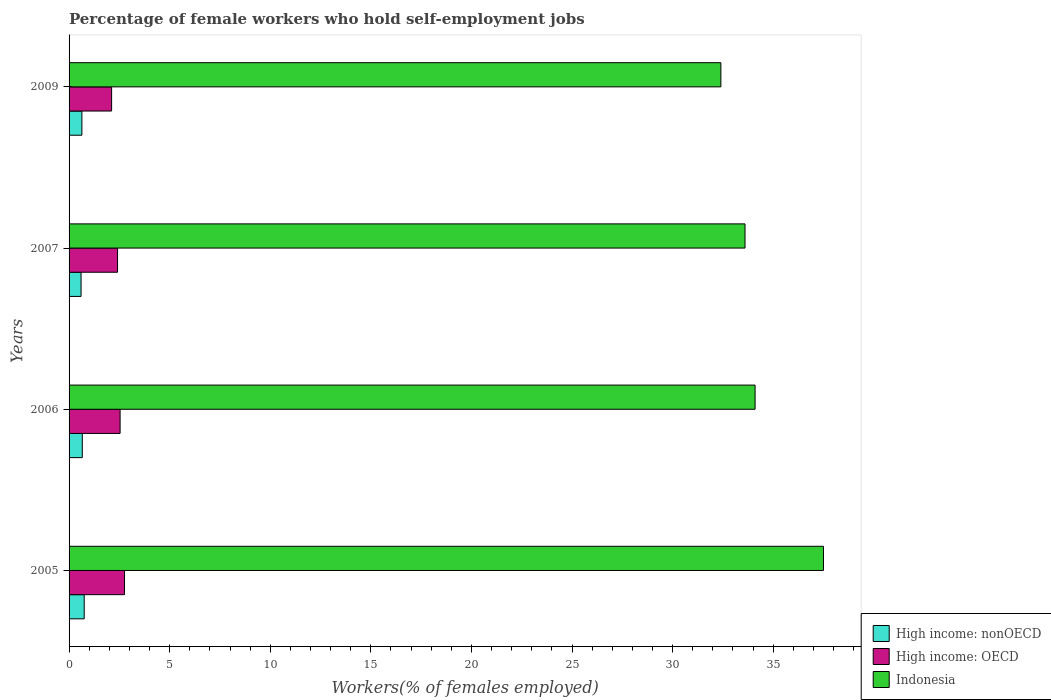What is the percentage of self-employed female workers in Indonesia in 2005?
Offer a very short reply. 37.5. Across all years, what is the maximum percentage of self-employed female workers in Indonesia?
Your answer should be compact. 37.5. Across all years, what is the minimum percentage of self-employed female workers in Indonesia?
Offer a very short reply. 32.4. In which year was the percentage of self-employed female workers in High income: nonOECD maximum?
Make the answer very short. 2005. What is the total percentage of self-employed female workers in High income: OECD in the graph?
Provide a short and direct response. 9.82. What is the difference between the percentage of self-employed female workers in High income: nonOECD in 2006 and that in 2007?
Provide a succinct answer. 0.06. What is the difference between the percentage of self-employed female workers in High income: nonOECD in 2005 and the percentage of self-employed female workers in Indonesia in 2009?
Your answer should be compact. -31.65. What is the average percentage of self-employed female workers in High income: nonOECD per year?
Provide a succinct answer. 0.66. In the year 2006, what is the difference between the percentage of self-employed female workers in High income: nonOECD and percentage of self-employed female workers in High income: OECD?
Provide a succinct answer. -1.88. In how many years, is the percentage of self-employed female workers in High income: OECD greater than 3 %?
Make the answer very short. 0. What is the ratio of the percentage of self-employed female workers in High income: nonOECD in 2006 to that in 2009?
Your response must be concise. 1.03. Is the difference between the percentage of self-employed female workers in High income: nonOECD in 2005 and 2007 greater than the difference between the percentage of self-employed female workers in High income: OECD in 2005 and 2007?
Offer a very short reply. No. What is the difference between the highest and the second highest percentage of self-employed female workers in Indonesia?
Your answer should be compact. 3.4. What is the difference between the highest and the lowest percentage of self-employed female workers in Indonesia?
Provide a succinct answer. 5.1. In how many years, is the percentage of self-employed female workers in High income: OECD greater than the average percentage of self-employed female workers in High income: OECD taken over all years?
Your response must be concise. 2. What does the 3rd bar from the top in 2005 represents?
Offer a very short reply. High income: nonOECD. Is it the case that in every year, the sum of the percentage of self-employed female workers in High income: OECD and percentage of self-employed female workers in Indonesia is greater than the percentage of self-employed female workers in High income: nonOECD?
Give a very brief answer. Yes. How many bars are there?
Offer a terse response. 12. Are all the bars in the graph horizontal?
Make the answer very short. Yes. How many years are there in the graph?
Provide a short and direct response. 4. Does the graph contain any zero values?
Keep it short and to the point. No. Does the graph contain grids?
Give a very brief answer. No. Where does the legend appear in the graph?
Make the answer very short. Bottom right. How many legend labels are there?
Keep it short and to the point. 3. What is the title of the graph?
Make the answer very short. Percentage of female workers who hold self-employment jobs. What is the label or title of the X-axis?
Your answer should be very brief. Workers(% of females employed). What is the label or title of the Y-axis?
Your answer should be very brief. Years. What is the Workers(% of females employed) in High income: nonOECD in 2005?
Provide a short and direct response. 0.75. What is the Workers(% of females employed) in High income: OECD in 2005?
Make the answer very short. 2.76. What is the Workers(% of females employed) in Indonesia in 2005?
Keep it short and to the point. 37.5. What is the Workers(% of females employed) of High income: nonOECD in 2006?
Give a very brief answer. 0.66. What is the Workers(% of females employed) of High income: OECD in 2006?
Your response must be concise. 2.54. What is the Workers(% of females employed) of Indonesia in 2006?
Provide a short and direct response. 34.1. What is the Workers(% of females employed) in High income: nonOECD in 2007?
Your answer should be compact. 0.6. What is the Workers(% of females employed) of High income: OECD in 2007?
Give a very brief answer. 2.41. What is the Workers(% of females employed) of Indonesia in 2007?
Your response must be concise. 33.6. What is the Workers(% of females employed) of High income: nonOECD in 2009?
Provide a short and direct response. 0.64. What is the Workers(% of females employed) of High income: OECD in 2009?
Your answer should be very brief. 2.11. What is the Workers(% of females employed) of Indonesia in 2009?
Provide a short and direct response. 32.4. Across all years, what is the maximum Workers(% of females employed) in High income: nonOECD?
Make the answer very short. 0.75. Across all years, what is the maximum Workers(% of females employed) in High income: OECD?
Your answer should be very brief. 2.76. Across all years, what is the maximum Workers(% of females employed) in Indonesia?
Offer a terse response. 37.5. Across all years, what is the minimum Workers(% of females employed) in High income: nonOECD?
Provide a succinct answer. 0.6. Across all years, what is the minimum Workers(% of females employed) in High income: OECD?
Provide a short and direct response. 2.11. Across all years, what is the minimum Workers(% of females employed) of Indonesia?
Keep it short and to the point. 32.4. What is the total Workers(% of females employed) of High income: nonOECD in the graph?
Keep it short and to the point. 2.64. What is the total Workers(% of females employed) of High income: OECD in the graph?
Provide a succinct answer. 9.82. What is the total Workers(% of females employed) in Indonesia in the graph?
Your answer should be very brief. 137.6. What is the difference between the Workers(% of females employed) of High income: nonOECD in 2005 and that in 2006?
Ensure brevity in your answer.  0.1. What is the difference between the Workers(% of females employed) in High income: OECD in 2005 and that in 2006?
Provide a succinct answer. 0.22. What is the difference between the Workers(% of females employed) of Indonesia in 2005 and that in 2006?
Your response must be concise. 3.4. What is the difference between the Workers(% of females employed) in High income: nonOECD in 2005 and that in 2007?
Your answer should be compact. 0.16. What is the difference between the Workers(% of females employed) of High income: OECD in 2005 and that in 2007?
Your answer should be very brief. 0.35. What is the difference between the Workers(% of females employed) of Indonesia in 2005 and that in 2007?
Provide a short and direct response. 3.9. What is the difference between the Workers(% of females employed) in High income: nonOECD in 2005 and that in 2009?
Ensure brevity in your answer.  0.11. What is the difference between the Workers(% of females employed) in High income: OECD in 2005 and that in 2009?
Offer a terse response. 0.64. What is the difference between the Workers(% of females employed) in High income: nonOECD in 2006 and that in 2007?
Provide a short and direct response. 0.06. What is the difference between the Workers(% of females employed) of High income: OECD in 2006 and that in 2007?
Make the answer very short. 0.13. What is the difference between the Workers(% of females employed) of Indonesia in 2006 and that in 2007?
Make the answer very short. 0.5. What is the difference between the Workers(% of females employed) of High income: nonOECD in 2006 and that in 2009?
Offer a very short reply. 0.02. What is the difference between the Workers(% of females employed) of High income: OECD in 2006 and that in 2009?
Offer a terse response. 0.42. What is the difference between the Workers(% of females employed) of High income: nonOECD in 2007 and that in 2009?
Your answer should be very brief. -0.04. What is the difference between the Workers(% of females employed) in High income: OECD in 2007 and that in 2009?
Give a very brief answer. 0.3. What is the difference between the Workers(% of females employed) in Indonesia in 2007 and that in 2009?
Offer a very short reply. 1.2. What is the difference between the Workers(% of females employed) in High income: nonOECD in 2005 and the Workers(% of females employed) in High income: OECD in 2006?
Ensure brevity in your answer.  -1.78. What is the difference between the Workers(% of females employed) in High income: nonOECD in 2005 and the Workers(% of females employed) in Indonesia in 2006?
Ensure brevity in your answer.  -33.35. What is the difference between the Workers(% of females employed) of High income: OECD in 2005 and the Workers(% of females employed) of Indonesia in 2006?
Offer a terse response. -31.34. What is the difference between the Workers(% of females employed) of High income: nonOECD in 2005 and the Workers(% of females employed) of High income: OECD in 2007?
Offer a terse response. -1.66. What is the difference between the Workers(% of females employed) in High income: nonOECD in 2005 and the Workers(% of females employed) in Indonesia in 2007?
Offer a terse response. -32.85. What is the difference between the Workers(% of females employed) of High income: OECD in 2005 and the Workers(% of females employed) of Indonesia in 2007?
Your answer should be compact. -30.84. What is the difference between the Workers(% of females employed) of High income: nonOECD in 2005 and the Workers(% of females employed) of High income: OECD in 2009?
Offer a very short reply. -1.36. What is the difference between the Workers(% of females employed) in High income: nonOECD in 2005 and the Workers(% of females employed) in Indonesia in 2009?
Make the answer very short. -31.65. What is the difference between the Workers(% of females employed) in High income: OECD in 2005 and the Workers(% of females employed) in Indonesia in 2009?
Your response must be concise. -29.64. What is the difference between the Workers(% of females employed) in High income: nonOECD in 2006 and the Workers(% of females employed) in High income: OECD in 2007?
Your answer should be very brief. -1.75. What is the difference between the Workers(% of females employed) of High income: nonOECD in 2006 and the Workers(% of females employed) of Indonesia in 2007?
Your response must be concise. -32.94. What is the difference between the Workers(% of females employed) of High income: OECD in 2006 and the Workers(% of females employed) of Indonesia in 2007?
Your answer should be compact. -31.06. What is the difference between the Workers(% of females employed) in High income: nonOECD in 2006 and the Workers(% of females employed) in High income: OECD in 2009?
Make the answer very short. -1.46. What is the difference between the Workers(% of females employed) of High income: nonOECD in 2006 and the Workers(% of females employed) of Indonesia in 2009?
Make the answer very short. -31.74. What is the difference between the Workers(% of females employed) of High income: OECD in 2006 and the Workers(% of females employed) of Indonesia in 2009?
Offer a very short reply. -29.86. What is the difference between the Workers(% of females employed) of High income: nonOECD in 2007 and the Workers(% of females employed) of High income: OECD in 2009?
Make the answer very short. -1.52. What is the difference between the Workers(% of females employed) in High income: nonOECD in 2007 and the Workers(% of females employed) in Indonesia in 2009?
Give a very brief answer. -31.8. What is the difference between the Workers(% of females employed) in High income: OECD in 2007 and the Workers(% of females employed) in Indonesia in 2009?
Ensure brevity in your answer.  -29.99. What is the average Workers(% of females employed) in High income: nonOECD per year?
Keep it short and to the point. 0.66. What is the average Workers(% of females employed) in High income: OECD per year?
Make the answer very short. 2.45. What is the average Workers(% of females employed) of Indonesia per year?
Offer a very short reply. 34.4. In the year 2005, what is the difference between the Workers(% of females employed) of High income: nonOECD and Workers(% of females employed) of High income: OECD?
Offer a terse response. -2. In the year 2005, what is the difference between the Workers(% of females employed) of High income: nonOECD and Workers(% of females employed) of Indonesia?
Your response must be concise. -36.75. In the year 2005, what is the difference between the Workers(% of females employed) of High income: OECD and Workers(% of females employed) of Indonesia?
Offer a very short reply. -34.74. In the year 2006, what is the difference between the Workers(% of females employed) in High income: nonOECD and Workers(% of females employed) in High income: OECD?
Provide a short and direct response. -1.88. In the year 2006, what is the difference between the Workers(% of females employed) in High income: nonOECD and Workers(% of females employed) in Indonesia?
Make the answer very short. -33.44. In the year 2006, what is the difference between the Workers(% of females employed) in High income: OECD and Workers(% of females employed) in Indonesia?
Your answer should be compact. -31.56. In the year 2007, what is the difference between the Workers(% of females employed) of High income: nonOECD and Workers(% of females employed) of High income: OECD?
Offer a very short reply. -1.81. In the year 2007, what is the difference between the Workers(% of females employed) of High income: nonOECD and Workers(% of females employed) of Indonesia?
Your answer should be compact. -33. In the year 2007, what is the difference between the Workers(% of females employed) in High income: OECD and Workers(% of females employed) in Indonesia?
Offer a terse response. -31.19. In the year 2009, what is the difference between the Workers(% of females employed) of High income: nonOECD and Workers(% of females employed) of High income: OECD?
Offer a terse response. -1.48. In the year 2009, what is the difference between the Workers(% of females employed) in High income: nonOECD and Workers(% of females employed) in Indonesia?
Make the answer very short. -31.76. In the year 2009, what is the difference between the Workers(% of females employed) of High income: OECD and Workers(% of females employed) of Indonesia?
Make the answer very short. -30.29. What is the ratio of the Workers(% of females employed) in High income: nonOECD in 2005 to that in 2006?
Offer a terse response. 1.15. What is the ratio of the Workers(% of females employed) of High income: OECD in 2005 to that in 2006?
Keep it short and to the point. 1.09. What is the ratio of the Workers(% of females employed) in Indonesia in 2005 to that in 2006?
Your answer should be very brief. 1.1. What is the ratio of the Workers(% of females employed) in High income: nonOECD in 2005 to that in 2007?
Provide a succinct answer. 1.26. What is the ratio of the Workers(% of females employed) in High income: OECD in 2005 to that in 2007?
Make the answer very short. 1.14. What is the ratio of the Workers(% of females employed) of Indonesia in 2005 to that in 2007?
Your response must be concise. 1.12. What is the ratio of the Workers(% of females employed) in High income: nonOECD in 2005 to that in 2009?
Ensure brevity in your answer.  1.18. What is the ratio of the Workers(% of females employed) in High income: OECD in 2005 to that in 2009?
Keep it short and to the point. 1.3. What is the ratio of the Workers(% of females employed) of Indonesia in 2005 to that in 2009?
Offer a very short reply. 1.16. What is the ratio of the Workers(% of females employed) of High income: nonOECD in 2006 to that in 2007?
Keep it short and to the point. 1.1. What is the ratio of the Workers(% of females employed) in High income: OECD in 2006 to that in 2007?
Provide a short and direct response. 1.05. What is the ratio of the Workers(% of females employed) of Indonesia in 2006 to that in 2007?
Provide a short and direct response. 1.01. What is the ratio of the Workers(% of females employed) of High income: nonOECD in 2006 to that in 2009?
Provide a short and direct response. 1.03. What is the ratio of the Workers(% of females employed) of High income: OECD in 2006 to that in 2009?
Make the answer very short. 1.2. What is the ratio of the Workers(% of females employed) of Indonesia in 2006 to that in 2009?
Provide a short and direct response. 1.05. What is the ratio of the Workers(% of females employed) of High income: nonOECD in 2007 to that in 2009?
Ensure brevity in your answer.  0.94. What is the ratio of the Workers(% of females employed) in High income: OECD in 2007 to that in 2009?
Your answer should be compact. 1.14. What is the difference between the highest and the second highest Workers(% of females employed) in High income: nonOECD?
Your answer should be compact. 0.1. What is the difference between the highest and the second highest Workers(% of females employed) in High income: OECD?
Keep it short and to the point. 0.22. What is the difference between the highest and the second highest Workers(% of females employed) in Indonesia?
Offer a very short reply. 3.4. What is the difference between the highest and the lowest Workers(% of females employed) in High income: nonOECD?
Give a very brief answer. 0.16. What is the difference between the highest and the lowest Workers(% of females employed) of High income: OECD?
Your response must be concise. 0.64. 